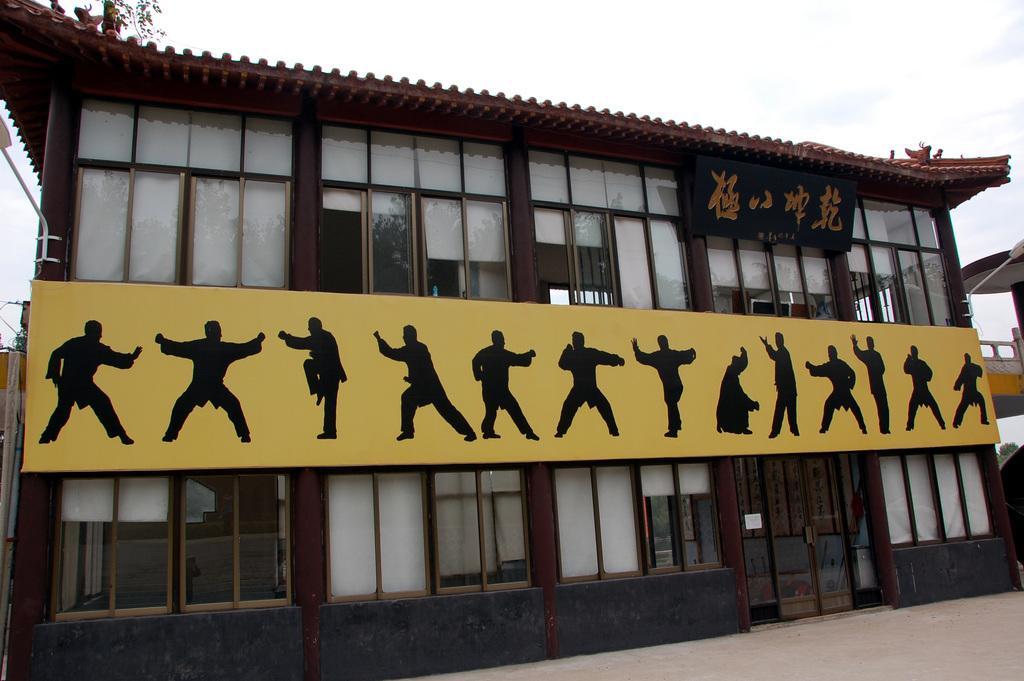How would you summarize this image in a sentence or two? In this image there is a building, boards, sky and objects. Something is written on the blackboard. On the yellow board I can see people in different positions.   